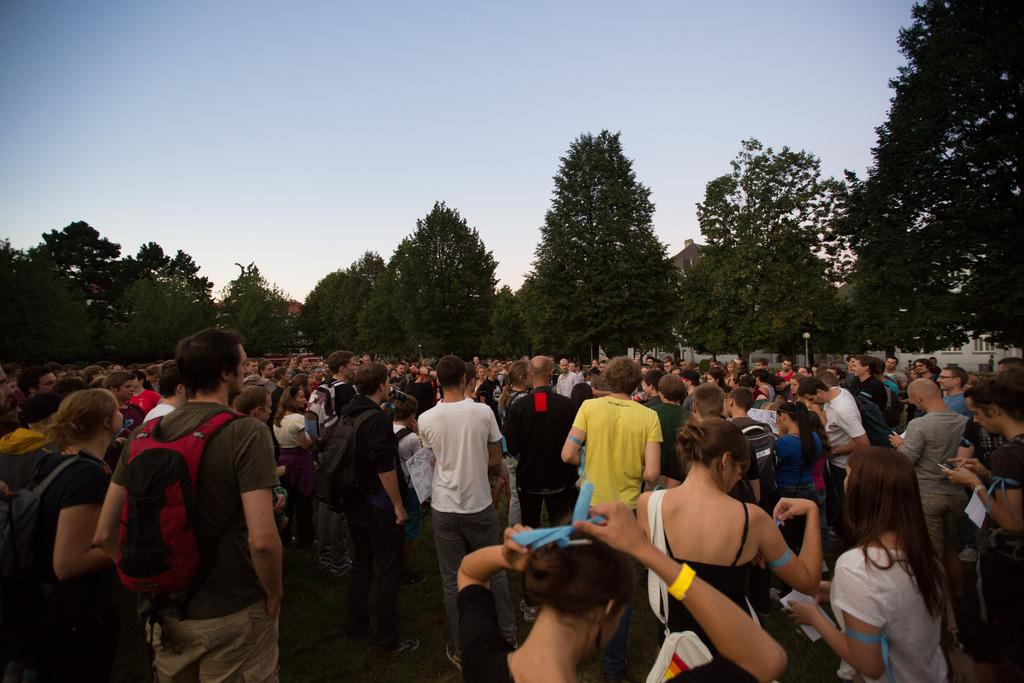How many people are in the image? There is a group of people in the image, but the exact number cannot be determined from the provided facts. Where are the people standing in the image? The people are standing on a path in the image. What is in front of the people? There is a pole in front of the people. What type of structures can be seen in the image? Houses are visible in the image. What other natural elements are present in the image? Trees are present in the image. What is visible in the background of the image? The sky is visible in the image. What type of knot is being tied by the people in the image? There is no knot-tying activity depicted in the image; the people are simply standing on a path. What type of furniture can be seen in the image? There is no furniture present in the image. 